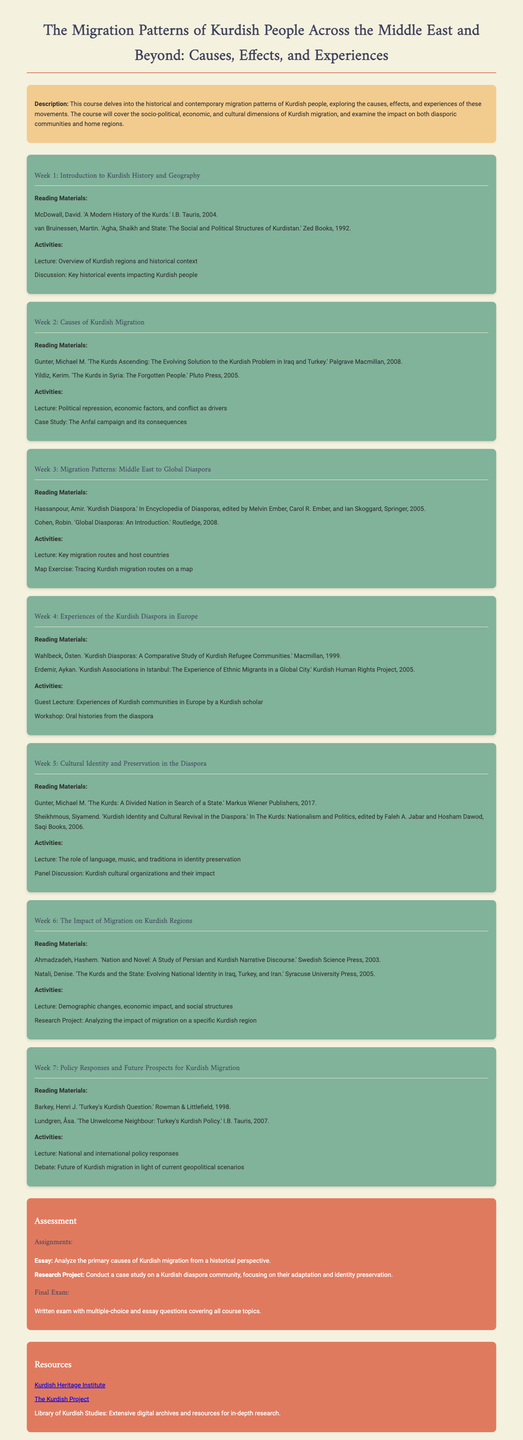What is the title of the course? The title of the course is stated at the beginning of the document.
Answer: The Migration Patterns of Kurdish People Across the Middle East and Beyond: Causes, Effects, and Experiences Who authored the book titled "A Modern History of the Kurds"? This information can be found in the reading materials section for Week 1.
Answer: McDowall, David What is one of the themes covered in Week 2? The activities for Week 2 include discussions on key factors leading to migration.
Answer: Political repression How many weeks are outlined in the syllabus? The number of weeks can be counted from the structured sections in the document.
Answer: Seven What type of project is due as part of the assessment? The assessment section specifies what type of assignments are required.
Answer: Research Project Which scholar is invited for a guest lecture in Week 4? The activities for Week 4 mention the guest speaker's background.
Answer: A Kurdish scholar What is the main focus of Week 6? Week 6 includes a lecture on the implications of migration on regions, indicating its theme.
Answer: The Impact of Migration on Kurdish Regions Which organization is listed as a resource in the document? The resources section provides links to organizations relevant to Kurdish studies.
Answer: Kurdish Heritage Institute 